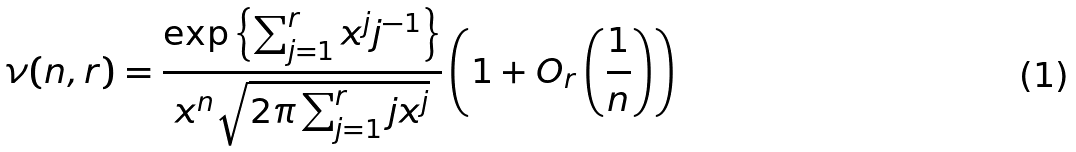Convert formula to latex. <formula><loc_0><loc_0><loc_500><loc_500>\nu ( n , r ) = \frac { \exp \left \{ \sum _ { j = 1 } ^ { r } { x ^ { j } j ^ { - 1 } } \right \} } { x ^ { n } \sqrt { 2 \pi \sum _ { j = 1 } ^ { r } j x ^ { j } } } \left ( 1 + O _ { r } \left ( \frac { 1 } { n } \right ) \right )</formula> 